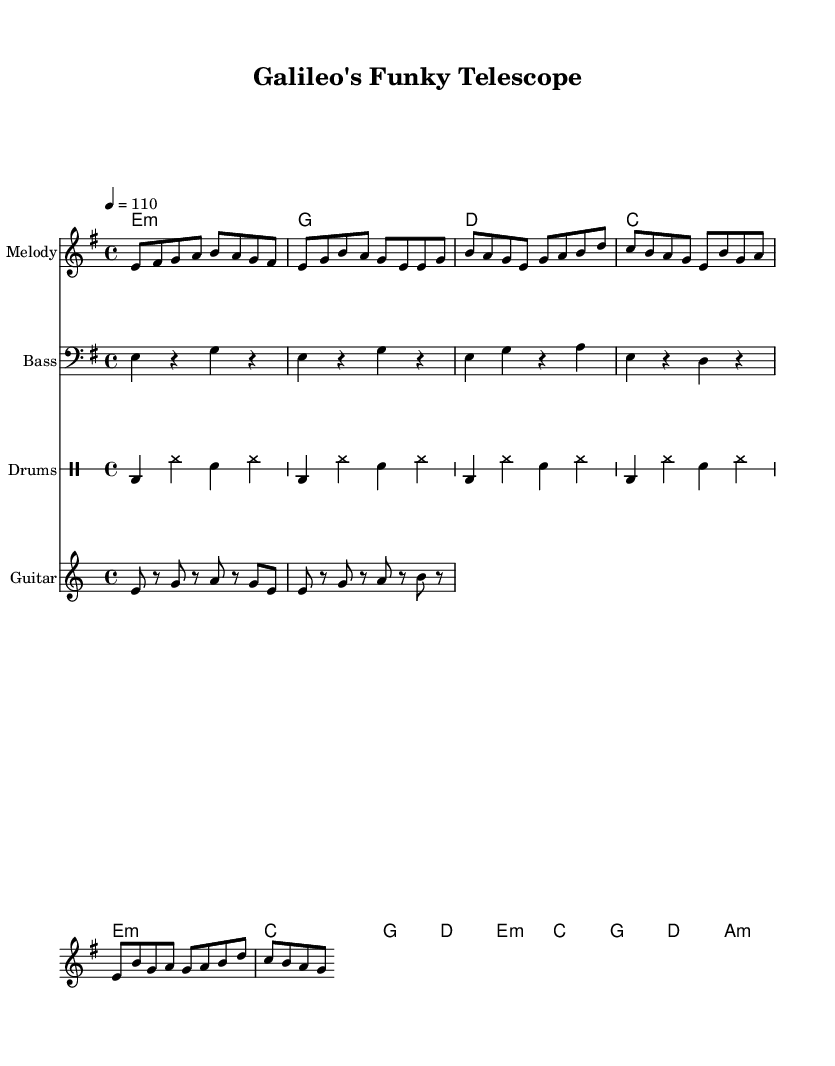What is the key signature of this music? The key signature is indicated by the sharp signs that appear on the staff. In this sheet music, there are three sharps (F#, C#, and G#), suggesting it is in E minor.
Answer: E minor What is the time signature of this music? The time signature is found at the beginning of the piece, represented as a fraction. Here, it shows 4/4, meaning there are four beats in each measure and a quarter note gets one beat.
Answer: 4/4 What is the tempo marking for this piece? The tempo marking is given as a metronome marking at the beginning of the score. It indicates "4 = 110", telling us the quarter note should be played at 110 beats per minute.
Answer: 110 How many measures are in the melody section? By counting the individual measures in the melody line provided, one can see there are a total of six measures in the melody section.
Answer: 6 What is the rhythmic pattern of the bass line? The bass line consists of a specific rhythmic pattern shown in the four quarter notes followed by a rest. Inspecting each measure reveals the recurring rhythm: quarter, rest, quarter, rest throughout the first four measures.
Answer: quarter-rest pattern Which section of the piece is referred to as the "Chorus"? The "Chorus" can be identified in the melody and chord sections. It is a distinct part of the structure, represented clearly following the "Verse" section, labeled as "Chorus" in the notation.
Answer: Chorus What type of ensemble is appropriate for performing this piece? Examining the instrumentation indicated on the score suggests it is arranged for a small group or band, which typically includes melody, bass, drums, and guitar, suitable for funk music styles.
Answer: small band 